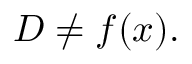Convert formula to latex. <formula><loc_0><loc_0><loc_500><loc_500>D \neq f ( x ) .</formula> 